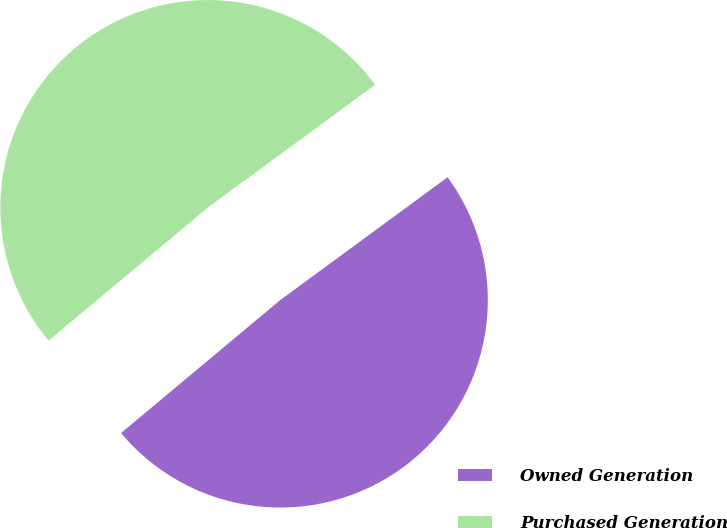Convert chart to OTSL. <chart><loc_0><loc_0><loc_500><loc_500><pie_chart><fcel>Owned Generation<fcel>Purchased Generation<nl><fcel>49.0%<fcel>51.0%<nl></chart> 